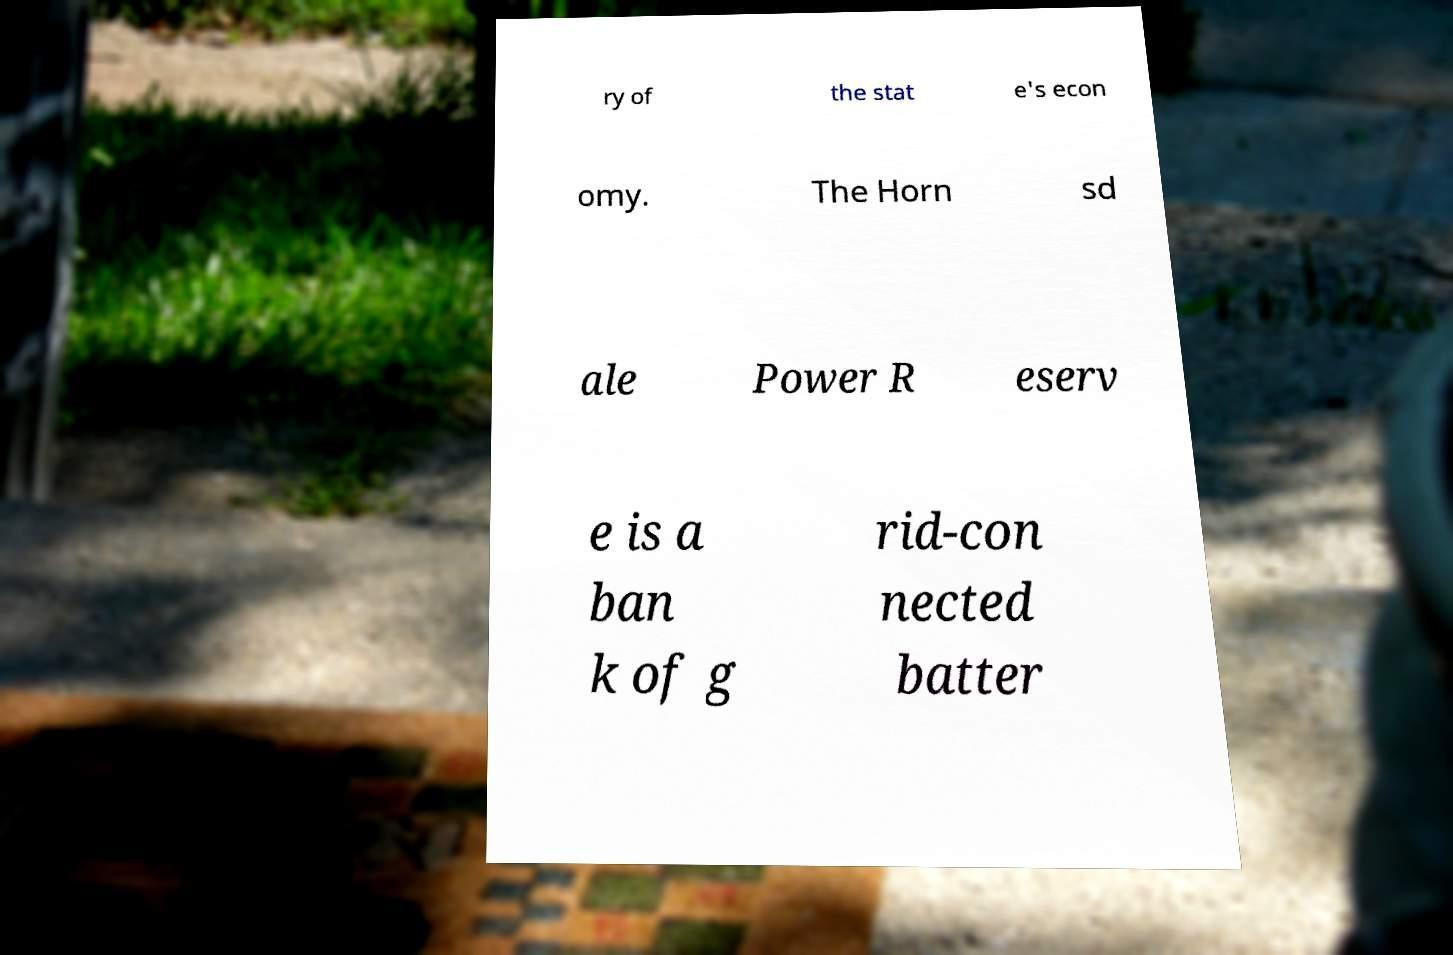Can you accurately transcribe the text from the provided image for me? ry of the stat e's econ omy. The Horn sd ale Power R eserv e is a ban k of g rid-con nected batter 